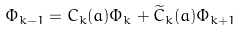Convert formula to latex. <formula><loc_0><loc_0><loc_500><loc_500>\Phi _ { k - 1 } = C _ { k } ( a ) \Phi _ { k } + \widetilde { C } _ { k } ( a ) \Phi _ { k + 1 }</formula> 